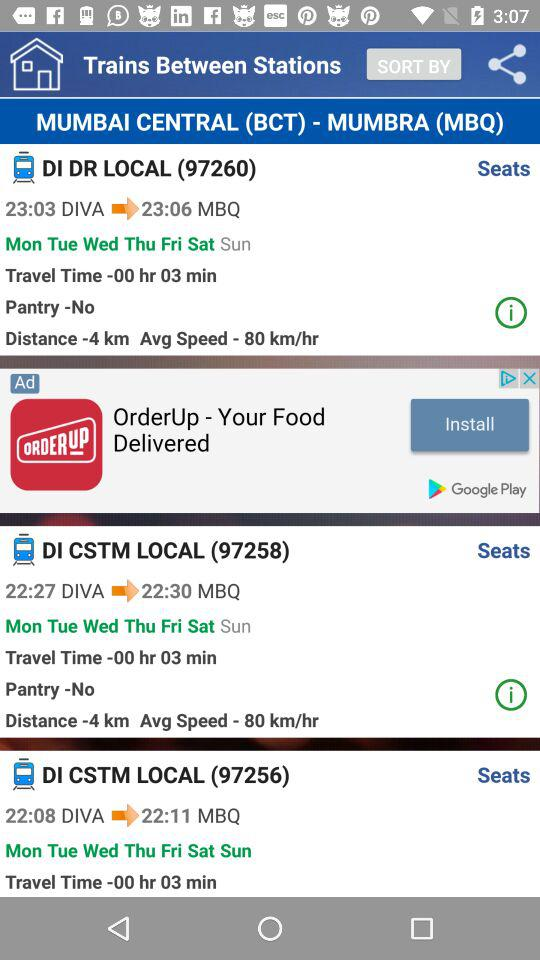What is the travel time of train "DI CSTM LOCAL (97258)"? The travel time of train "DI CSTM LOCAL (97258)" is 3 minutes. 